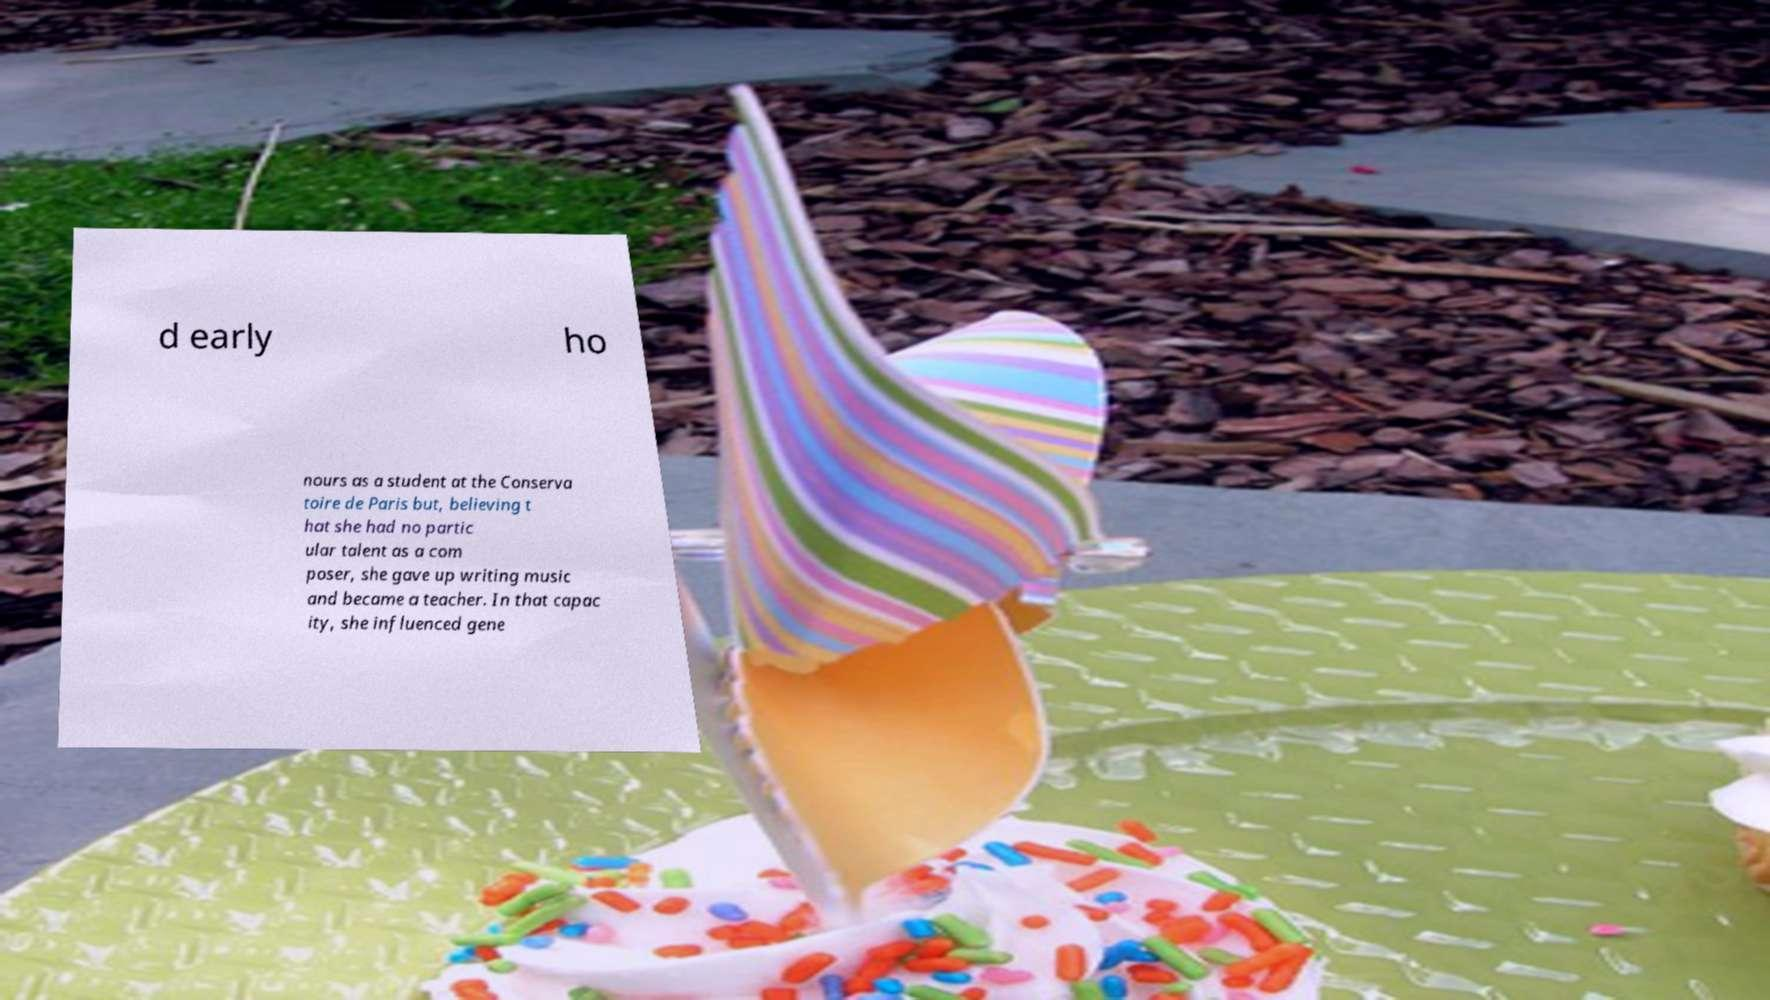Please identify and transcribe the text found in this image. d early ho nours as a student at the Conserva toire de Paris but, believing t hat she had no partic ular talent as a com poser, she gave up writing music and became a teacher. In that capac ity, she influenced gene 